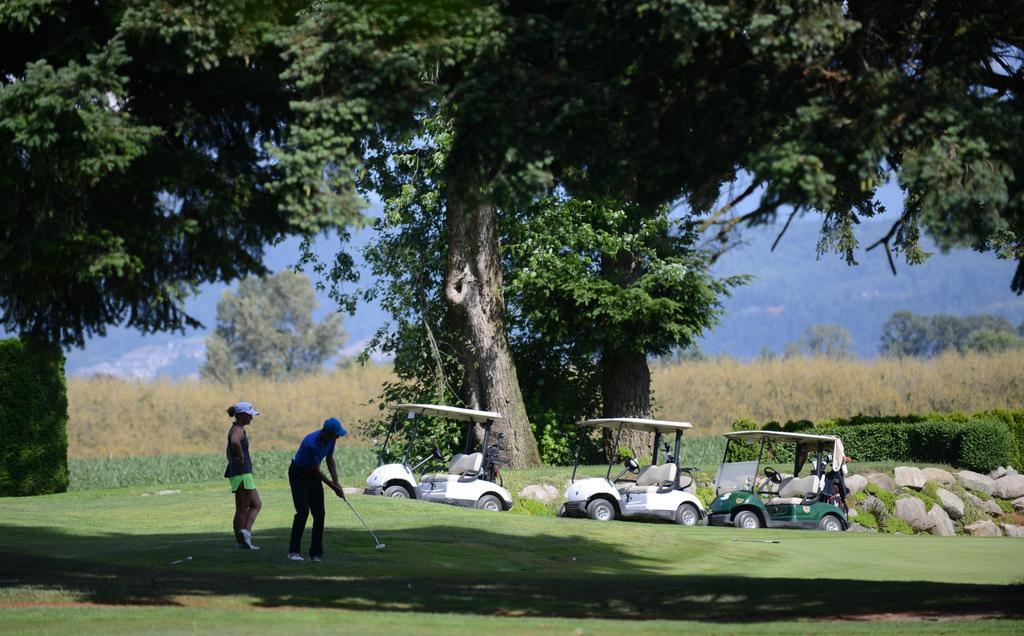In one or two sentences, can you explain what this image depicts? In front of the image there is a person holding the stick. Behind him there is another person standing. There are vehicles. At the bottom of the image there is grass on the surface. In the background of the image there are bushes, trees. At the top of the image there is sky. 